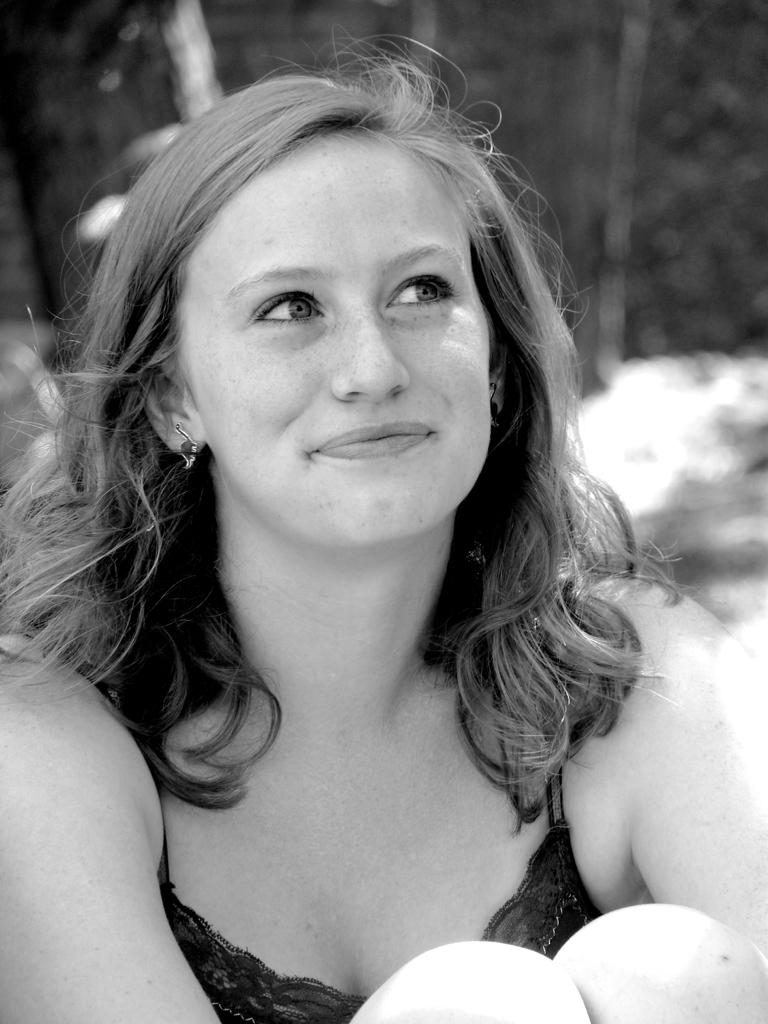Who is the main subject in the image? There is a woman in the image. What is the woman wearing? The woman is wearing a black dress. What is the woman's position in the image? The woman is sitting on the ground. What can be seen in the background of the image? There is a wall in the background of the image. What type of debt is the woman discussing in the image? There is no indication in the image that the woman is discussing any type of debt. 